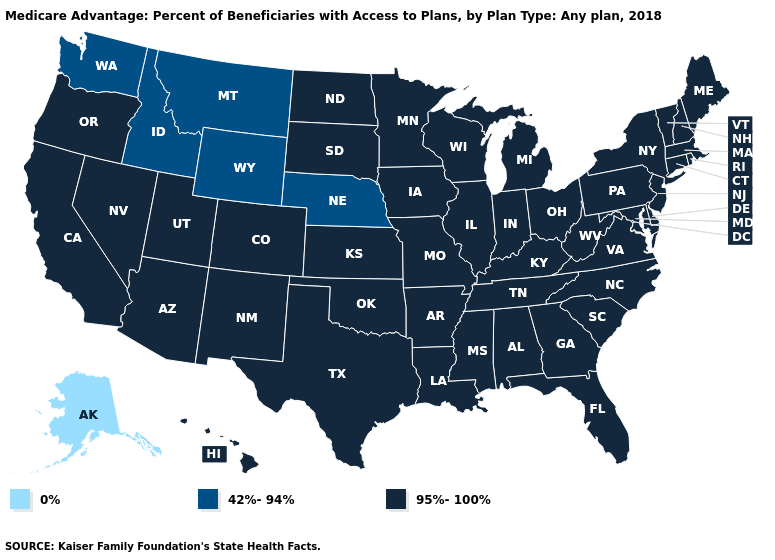Name the states that have a value in the range 95%-100%?
Quick response, please. California, Colorado, Connecticut, Delaware, Florida, Georgia, Hawaii, Iowa, Illinois, Indiana, Kansas, Kentucky, Louisiana, Massachusetts, Maryland, Maine, Michigan, Minnesota, Missouri, Mississippi, North Carolina, North Dakota, New Hampshire, New Jersey, New Mexico, Nevada, New York, Ohio, Oklahoma, Oregon, Pennsylvania, Rhode Island, South Carolina, South Dakota, Tennessee, Texas, Utah, Virginia, Vermont, Wisconsin, West Virginia, Alabama, Arkansas, Arizona. Does Hawaii have the same value as Massachusetts?
Concise answer only. Yes. Among the states that border Utah , does Nevada have the highest value?
Answer briefly. Yes. What is the value of Rhode Island?
Be succinct. 95%-100%. Is the legend a continuous bar?
Write a very short answer. No. Does Montana have the highest value in the West?
Quick response, please. No. Which states hav the highest value in the West?
Concise answer only. California, Colorado, Hawaii, New Mexico, Nevada, Oregon, Utah, Arizona. What is the highest value in the USA?
Concise answer only. 95%-100%. Among the states that border Missouri , does Nebraska have the highest value?
Short answer required. No. What is the lowest value in the USA?
Keep it brief. 0%. What is the highest value in states that border Idaho?
Quick response, please. 95%-100%. Which states hav the highest value in the MidWest?
Short answer required. Iowa, Illinois, Indiana, Kansas, Michigan, Minnesota, Missouri, North Dakota, Ohio, South Dakota, Wisconsin. 